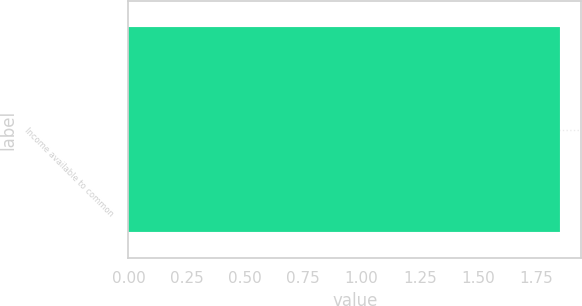<chart> <loc_0><loc_0><loc_500><loc_500><bar_chart><fcel>Income available to common<nl><fcel>1.85<nl></chart> 